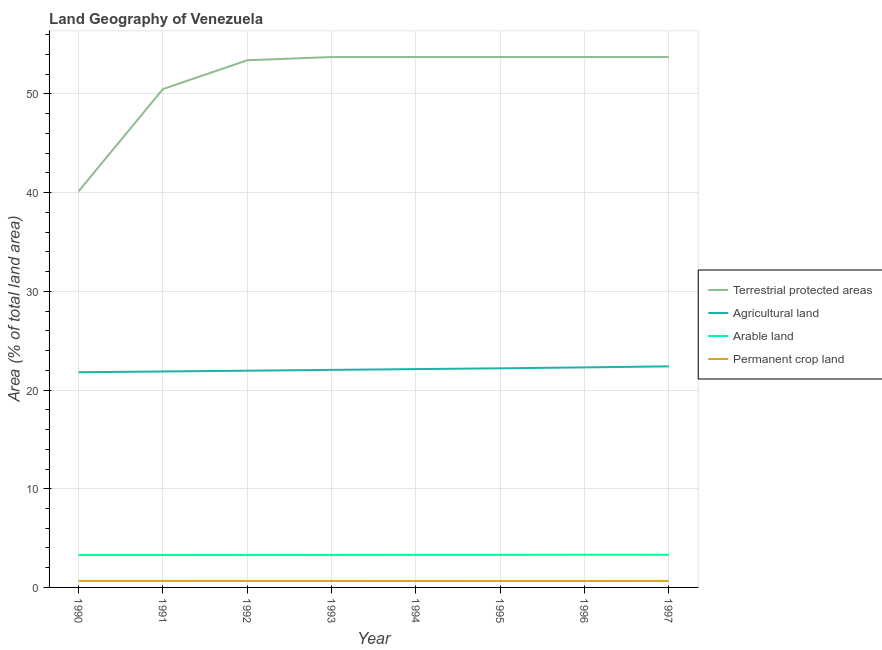Does the line corresponding to percentage of land under terrestrial protection intersect with the line corresponding to percentage of area under agricultural land?
Your answer should be very brief. No. What is the percentage of land under terrestrial protection in 1997?
Give a very brief answer. 53.75. Across all years, what is the maximum percentage of area under permanent crop land?
Give a very brief answer. 0.66. Across all years, what is the minimum percentage of area under permanent crop land?
Make the answer very short. 0.65. In which year was the percentage of land under terrestrial protection maximum?
Make the answer very short. 1993. What is the total percentage of area under permanent crop land in the graph?
Keep it short and to the point. 5.23. What is the difference between the percentage of area under arable land in 1993 and that in 1994?
Your answer should be compact. -0. What is the difference between the percentage of area under permanent crop land in 1992 and the percentage of land under terrestrial protection in 1993?
Offer a terse response. -53.09. What is the average percentage of area under permanent crop land per year?
Offer a very short reply. 0.65. In the year 1996, what is the difference between the percentage of area under agricultural land and percentage of area under permanent crop land?
Your response must be concise. 21.65. What is the ratio of the percentage of area under arable land in 1990 to that in 1992?
Your response must be concise. 1. Is the percentage of area under agricultural land in 1991 less than that in 1994?
Give a very brief answer. Yes. What is the difference between the highest and the second highest percentage of area under agricultural land?
Ensure brevity in your answer.  0.1. What is the difference between the highest and the lowest percentage of area under arable land?
Your answer should be very brief. 0.02. Is the sum of the percentage of area under arable land in 1993 and 1995 greater than the maximum percentage of area under permanent crop land across all years?
Give a very brief answer. Yes. Is it the case that in every year, the sum of the percentage of land under terrestrial protection and percentage of area under agricultural land is greater than the sum of percentage of area under arable land and percentage of area under permanent crop land?
Offer a very short reply. No. Does the percentage of area under permanent crop land monotonically increase over the years?
Provide a short and direct response. No. Is the percentage of area under permanent crop land strictly less than the percentage of area under arable land over the years?
Your answer should be compact. Yes. How are the legend labels stacked?
Make the answer very short. Vertical. What is the title of the graph?
Provide a succinct answer. Land Geography of Venezuela. What is the label or title of the X-axis?
Provide a short and direct response. Year. What is the label or title of the Y-axis?
Offer a terse response. Area (% of total land area). What is the Area (% of total land area) of Terrestrial protected areas in 1990?
Your answer should be compact. 40.15. What is the Area (% of total land area) of Agricultural land in 1990?
Provide a short and direct response. 21.8. What is the Area (% of total land area) in Arable land in 1990?
Offer a very short reply. 3.29. What is the Area (% of total land area) of Permanent crop land in 1990?
Your answer should be very brief. 0.66. What is the Area (% of total land area) of Terrestrial protected areas in 1991?
Your answer should be very brief. 50.5. What is the Area (% of total land area) of Agricultural land in 1991?
Keep it short and to the point. 21.88. What is the Area (% of total land area) in Arable land in 1991?
Give a very brief answer. 3.29. What is the Area (% of total land area) in Permanent crop land in 1991?
Provide a succinct answer. 0.66. What is the Area (% of total land area) of Terrestrial protected areas in 1992?
Ensure brevity in your answer.  53.42. What is the Area (% of total land area) in Agricultural land in 1992?
Your answer should be very brief. 21.96. What is the Area (% of total land area) in Arable land in 1992?
Offer a very short reply. 3.29. What is the Area (% of total land area) of Permanent crop land in 1992?
Offer a very short reply. 0.66. What is the Area (% of total land area) in Terrestrial protected areas in 1993?
Your answer should be compact. 53.75. What is the Area (% of total land area) of Agricultural land in 1993?
Ensure brevity in your answer.  22.04. What is the Area (% of total land area) of Arable land in 1993?
Make the answer very short. 3.3. What is the Area (% of total land area) of Permanent crop land in 1993?
Offer a very short reply. 0.65. What is the Area (% of total land area) in Terrestrial protected areas in 1994?
Ensure brevity in your answer.  53.75. What is the Area (% of total land area) in Agricultural land in 1994?
Ensure brevity in your answer.  22.12. What is the Area (% of total land area) of Arable land in 1994?
Offer a very short reply. 3.3. What is the Area (% of total land area) in Permanent crop land in 1994?
Your answer should be compact. 0.65. What is the Area (% of total land area) of Terrestrial protected areas in 1995?
Your response must be concise. 53.75. What is the Area (% of total land area) in Agricultural land in 1995?
Offer a very short reply. 22.2. What is the Area (% of total land area) of Arable land in 1995?
Keep it short and to the point. 3.3. What is the Area (% of total land area) in Permanent crop land in 1995?
Provide a succinct answer. 0.65. What is the Area (% of total land area) in Terrestrial protected areas in 1996?
Offer a very short reply. 53.75. What is the Area (% of total land area) in Agricultural land in 1996?
Give a very brief answer. 22.3. What is the Area (% of total land area) in Arable land in 1996?
Your answer should be compact. 3.31. What is the Area (% of total land area) in Permanent crop land in 1996?
Provide a short and direct response. 0.65. What is the Area (% of total land area) of Terrestrial protected areas in 1997?
Keep it short and to the point. 53.75. What is the Area (% of total land area) of Agricultural land in 1997?
Your answer should be compact. 22.4. What is the Area (% of total land area) in Arable land in 1997?
Give a very brief answer. 3.31. What is the Area (% of total land area) of Permanent crop land in 1997?
Offer a terse response. 0.66. Across all years, what is the maximum Area (% of total land area) of Terrestrial protected areas?
Ensure brevity in your answer.  53.75. Across all years, what is the maximum Area (% of total land area) in Agricultural land?
Make the answer very short. 22.4. Across all years, what is the maximum Area (% of total land area) in Arable land?
Your answer should be very brief. 3.31. Across all years, what is the maximum Area (% of total land area) of Permanent crop land?
Give a very brief answer. 0.66. Across all years, what is the minimum Area (% of total land area) of Terrestrial protected areas?
Your response must be concise. 40.15. Across all years, what is the minimum Area (% of total land area) in Agricultural land?
Your answer should be compact. 21.8. Across all years, what is the minimum Area (% of total land area) of Arable land?
Your response must be concise. 3.29. Across all years, what is the minimum Area (% of total land area) of Permanent crop land?
Keep it short and to the point. 0.65. What is the total Area (% of total land area) of Terrestrial protected areas in the graph?
Your answer should be very brief. 412.79. What is the total Area (% of total land area) of Agricultural land in the graph?
Make the answer very short. 176.72. What is the total Area (% of total land area) in Arable land in the graph?
Ensure brevity in your answer.  26.39. What is the total Area (% of total land area) in Permanent crop land in the graph?
Keep it short and to the point. 5.23. What is the difference between the Area (% of total land area) of Terrestrial protected areas in 1990 and that in 1991?
Your response must be concise. -10.36. What is the difference between the Area (% of total land area) in Agricultural land in 1990 and that in 1991?
Your answer should be very brief. -0.08. What is the difference between the Area (% of total land area) in Arable land in 1990 and that in 1991?
Provide a short and direct response. 0. What is the difference between the Area (% of total land area) of Terrestrial protected areas in 1990 and that in 1992?
Make the answer very short. -13.27. What is the difference between the Area (% of total land area) of Agricultural land in 1990 and that in 1992?
Ensure brevity in your answer.  -0.16. What is the difference between the Area (% of total land area) of Arable land in 1990 and that in 1992?
Provide a short and direct response. -0. What is the difference between the Area (% of total land area) in Permanent crop land in 1990 and that in 1992?
Ensure brevity in your answer.  0. What is the difference between the Area (% of total land area) of Terrestrial protected areas in 1990 and that in 1993?
Give a very brief answer. -13.6. What is the difference between the Area (% of total land area) in Agricultural land in 1990 and that in 1993?
Provide a short and direct response. -0.24. What is the difference between the Area (% of total land area) of Arable land in 1990 and that in 1993?
Your response must be concise. -0.01. What is the difference between the Area (% of total land area) of Permanent crop land in 1990 and that in 1993?
Keep it short and to the point. 0.01. What is the difference between the Area (% of total land area) of Terrestrial protected areas in 1990 and that in 1994?
Provide a succinct answer. -13.6. What is the difference between the Area (% of total land area) in Agricultural land in 1990 and that in 1994?
Provide a short and direct response. -0.32. What is the difference between the Area (% of total land area) in Arable land in 1990 and that in 1994?
Your answer should be compact. -0.01. What is the difference between the Area (% of total land area) of Permanent crop land in 1990 and that in 1994?
Offer a very short reply. 0.01. What is the difference between the Area (% of total land area) of Terrestrial protected areas in 1990 and that in 1995?
Make the answer very short. -13.6. What is the difference between the Area (% of total land area) of Agricultural land in 1990 and that in 1995?
Your response must be concise. -0.4. What is the difference between the Area (% of total land area) of Arable land in 1990 and that in 1995?
Your answer should be compact. -0.01. What is the difference between the Area (% of total land area) of Permanent crop land in 1990 and that in 1995?
Keep it short and to the point. 0.01. What is the difference between the Area (% of total land area) of Terrestrial protected areas in 1990 and that in 1996?
Keep it short and to the point. -13.6. What is the difference between the Area (% of total land area) in Agricultural land in 1990 and that in 1996?
Provide a succinct answer. -0.49. What is the difference between the Area (% of total land area) of Arable land in 1990 and that in 1996?
Provide a short and direct response. -0.02. What is the difference between the Area (% of total land area) of Permanent crop land in 1990 and that in 1996?
Keep it short and to the point. 0.01. What is the difference between the Area (% of total land area) in Terrestrial protected areas in 1990 and that in 1997?
Your answer should be very brief. -13.6. What is the difference between the Area (% of total land area) in Agricultural land in 1990 and that in 1997?
Offer a very short reply. -0.6. What is the difference between the Area (% of total land area) of Arable land in 1990 and that in 1997?
Give a very brief answer. -0.02. What is the difference between the Area (% of total land area) in Permanent crop land in 1990 and that in 1997?
Provide a succinct answer. 0. What is the difference between the Area (% of total land area) in Terrestrial protected areas in 1991 and that in 1992?
Provide a succinct answer. -2.92. What is the difference between the Area (% of total land area) of Agricultural land in 1991 and that in 1992?
Offer a terse response. -0.08. What is the difference between the Area (% of total land area) of Arable land in 1991 and that in 1992?
Provide a short and direct response. -0. What is the difference between the Area (% of total land area) in Permanent crop land in 1991 and that in 1992?
Provide a succinct answer. 0. What is the difference between the Area (% of total land area) in Terrestrial protected areas in 1991 and that in 1993?
Your answer should be compact. -3.25. What is the difference between the Area (% of total land area) in Agricultural land in 1991 and that in 1993?
Your response must be concise. -0.16. What is the difference between the Area (% of total land area) in Arable land in 1991 and that in 1993?
Provide a short and direct response. -0.01. What is the difference between the Area (% of total land area) of Permanent crop land in 1991 and that in 1993?
Offer a terse response. 0.01. What is the difference between the Area (% of total land area) of Terrestrial protected areas in 1991 and that in 1994?
Your answer should be very brief. -3.25. What is the difference between the Area (% of total land area) of Agricultural land in 1991 and that in 1994?
Provide a succinct answer. -0.24. What is the difference between the Area (% of total land area) of Arable land in 1991 and that in 1994?
Your answer should be compact. -0.01. What is the difference between the Area (% of total land area) in Permanent crop land in 1991 and that in 1994?
Your answer should be compact. 0.01. What is the difference between the Area (% of total land area) of Terrestrial protected areas in 1991 and that in 1995?
Give a very brief answer. -3.25. What is the difference between the Area (% of total land area) of Agricultural land in 1991 and that in 1995?
Provide a short and direct response. -0.32. What is the difference between the Area (% of total land area) of Arable land in 1991 and that in 1995?
Give a very brief answer. -0.01. What is the difference between the Area (% of total land area) of Permanent crop land in 1991 and that in 1995?
Offer a very short reply. 0.01. What is the difference between the Area (% of total land area) in Terrestrial protected areas in 1991 and that in 1996?
Provide a short and direct response. -3.25. What is the difference between the Area (% of total land area) of Agricultural land in 1991 and that in 1996?
Ensure brevity in your answer.  -0.41. What is the difference between the Area (% of total land area) of Arable land in 1991 and that in 1996?
Make the answer very short. -0.02. What is the difference between the Area (% of total land area) in Permanent crop land in 1991 and that in 1996?
Give a very brief answer. 0.01. What is the difference between the Area (% of total land area) of Terrestrial protected areas in 1991 and that in 1997?
Make the answer very short. -3.25. What is the difference between the Area (% of total land area) in Agricultural land in 1991 and that in 1997?
Ensure brevity in your answer.  -0.52. What is the difference between the Area (% of total land area) in Arable land in 1991 and that in 1997?
Provide a succinct answer. -0.02. What is the difference between the Area (% of total land area) of Permanent crop land in 1991 and that in 1997?
Provide a succinct answer. 0. What is the difference between the Area (% of total land area) in Terrestrial protected areas in 1992 and that in 1993?
Ensure brevity in your answer.  -0.33. What is the difference between the Area (% of total land area) in Agricultural land in 1992 and that in 1993?
Keep it short and to the point. -0.08. What is the difference between the Area (% of total land area) in Arable land in 1992 and that in 1993?
Ensure brevity in your answer.  -0. What is the difference between the Area (% of total land area) in Permanent crop land in 1992 and that in 1993?
Make the answer very short. 0. What is the difference between the Area (% of total land area) of Terrestrial protected areas in 1992 and that in 1994?
Your answer should be very brief. -0.33. What is the difference between the Area (% of total land area) of Agricultural land in 1992 and that in 1994?
Make the answer very short. -0.16. What is the difference between the Area (% of total land area) in Arable land in 1992 and that in 1994?
Give a very brief answer. -0.01. What is the difference between the Area (% of total land area) of Permanent crop land in 1992 and that in 1994?
Provide a short and direct response. 0.01. What is the difference between the Area (% of total land area) in Terrestrial protected areas in 1992 and that in 1995?
Give a very brief answer. -0.33. What is the difference between the Area (% of total land area) of Agricultural land in 1992 and that in 1995?
Provide a succinct answer. -0.24. What is the difference between the Area (% of total land area) in Arable land in 1992 and that in 1995?
Ensure brevity in your answer.  -0.01. What is the difference between the Area (% of total land area) in Permanent crop land in 1992 and that in 1995?
Offer a very short reply. 0.01. What is the difference between the Area (% of total land area) of Terrestrial protected areas in 1992 and that in 1996?
Provide a succinct answer. -0.33. What is the difference between the Area (% of total land area) of Arable land in 1992 and that in 1996?
Offer a very short reply. -0.02. What is the difference between the Area (% of total land area) of Permanent crop land in 1992 and that in 1996?
Make the answer very short. 0.01. What is the difference between the Area (% of total land area) in Terrestrial protected areas in 1992 and that in 1997?
Give a very brief answer. -0.33. What is the difference between the Area (% of total land area) in Agricultural land in 1992 and that in 1997?
Offer a very short reply. -0.44. What is the difference between the Area (% of total land area) of Arable land in 1992 and that in 1997?
Make the answer very short. -0.02. What is the difference between the Area (% of total land area) of Permanent crop land in 1992 and that in 1997?
Keep it short and to the point. 0. What is the difference between the Area (% of total land area) in Terrestrial protected areas in 1993 and that in 1994?
Make the answer very short. 0. What is the difference between the Area (% of total land area) in Agricultural land in 1993 and that in 1994?
Keep it short and to the point. -0.08. What is the difference between the Area (% of total land area) of Arable land in 1993 and that in 1994?
Ensure brevity in your answer.  -0. What is the difference between the Area (% of total land area) of Permanent crop land in 1993 and that in 1994?
Your answer should be compact. 0. What is the difference between the Area (% of total land area) of Terrestrial protected areas in 1993 and that in 1995?
Your answer should be compact. 0. What is the difference between the Area (% of total land area) of Agricultural land in 1993 and that in 1995?
Offer a very short reply. -0.16. What is the difference between the Area (% of total land area) in Arable land in 1993 and that in 1995?
Provide a succinct answer. -0.01. What is the difference between the Area (% of total land area) in Permanent crop land in 1993 and that in 1995?
Make the answer very short. 0.01. What is the difference between the Area (% of total land area) of Terrestrial protected areas in 1993 and that in 1996?
Your response must be concise. 0. What is the difference between the Area (% of total land area) in Agricultural land in 1993 and that in 1996?
Offer a terse response. -0.25. What is the difference between the Area (% of total land area) of Arable land in 1993 and that in 1996?
Offer a very short reply. -0.02. What is the difference between the Area (% of total land area) of Permanent crop land in 1993 and that in 1996?
Offer a terse response. 0. What is the difference between the Area (% of total land area) in Terrestrial protected areas in 1993 and that in 1997?
Make the answer very short. 0. What is the difference between the Area (% of total land area) in Agricultural land in 1993 and that in 1997?
Offer a very short reply. -0.36. What is the difference between the Area (% of total land area) in Arable land in 1993 and that in 1997?
Keep it short and to the point. -0.01. What is the difference between the Area (% of total land area) in Permanent crop land in 1993 and that in 1997?
Ensure brevity in your answer.  -0. What is the difference between the Area (% of total land area) of Agricultural land in 1994 and that in 1995?
Your answer should be very brief. -0.08. What is the difference between the Area (% of total land area) in Arable land in 1994 and that in 1995?
Provide a succinct answer. -0. What is the difference between the Area (% of total land area) in Permanent crop land in 1994 and that in 1995?
Your answer should be very brief. 0. What is the difference between the Area (% of total land area) in Terrestrial protected areas in 1994 and that in 1996?
Your response must be concise. 0. What is the difference between the Area (% of total land area) of Agricultural land in 1994 and that in 1996?
Offer a terse response. -0.17. What is the difference between the Area (% of total land area) of Arable land in 1994 and that in 1996?
Give a very brief answer. -0.01. What is the difference between the Area (% of total land area) of Permanent crop land in 1994 and that in 1996?
Give a very brief answer. -0. What is the difference between the Area (% of total land area) of Terrestrial protected areas in 1994 and that in 1997?
Provide a succinct answer. 0. What is the difference between the Area (% of total land area) of Agricultural land in 1994 and that in 1997?
Make the answer very short. -0.28. What is the difference between the Area (% of total land area) in Arable land in 1994 and that in 1997?
Your answer should be very brief. -0.01. What is the difference between the Area (% of total land area) in Permanent crop land in 1994 and that in 1997?
Provide a succinct answer. -0.01. What is the difference between the Area (% of total land area) in Terrestrial protected areas in 1995 and that in 1996?
Give a very brief answer. 0. What is the difference between the Area (% of total land area) of Agricultural land in 1995 and that in 1996?
Offer a terse response. -0.09. What is the difference between the Area (% of total land area) of Arable land in 1995 and that in 1996?
Keep it short and to the point. -0.01. What is the difference between the Area (% of total land area) of Permanent crop land in 1995 and that in 1996?
Give a very brief answer. -0. What is the difference between the Area (% of total land area) in Agricultural land in 1995 and that in 1997?
Provide a short and direct response. -0.2. What is the difference between the Area (% of total land area) in Arable land in 1995 and that in 1997?
Offer a very short reply. -0.01. What is the difference between the Area (% of total land area) in Permanent crop land in 1995 and that in 1997?
Provide a short and direct response. -0.01. What is the difference between the Area (% of total land area) of Terrestrial protected areas in 1996 and that in 1997?
Ensure brevity in your answer.  0. What is the difference between the Area (% of total land area) of Agricultural land in 1996 and that in 1997?
Provide a short and direct response. -0.1. What is the difference between the Area (% of total land area) of Arable land in 1996 and that in 1997?
Give a very brief answer. 0. What is the difference between the Area (% of total land area) in Permanent crop land in 1996 and that in 1997?
Offer a very short reply. -0.01. What is the difference between the Area (% of total land area) of Terrestrial protected areas in 1990 and the Area (% of total land area) of Agricultural land in 1991?
Provide a short and direct response. 18.26. What is the difference between the Area (% of total land area) in Terrestrial protected areas in 1990 and the Area (% of total land area) in Arable land in 1991?
Offer a terse response. 36.86. What is the difference between the Area (% of total land area) of Terrestrial protected areas in 1990 and the Area (% of total land area) of Permanent crop land in 1991?
Provide a short and direct response. 39.49. What is the difference between the Area (% of total land area) in Agricultural land in 1990 and the Area (% of total land area) in Arable land in 1991?
Your answer should be very brief. 18.52. What is the difference between the Area (% of total land area) of Agricultural land in 1990 and the Area (% of total land area) of Permanent crop land in 1991?
Offer a terse response. 21.14. What is the difference between the Area (% of total land area) of Arable land in 1990 and the Area (% of total land area) of Permanent crop land in 1991?
Offer a very short reply. 2.63. What is the difference between the Area (% of total land area) of Terrestrial protected areas in 1990 and the Area (% of total land area) of Agricultural land in 1992?
Offer a very short reply. 18.18. What is the difference between the Area (% of total land area) of Terrestrial protected areas in 1990 and the Area (% of total land area) of Arable land in 1992?
Offer a very short reply. 36.85. What is the difference between the Area (% of total land area) in Terrestrial protected areas in 1990 and the Area (% of total land area) in Permanent crop land in 1992?
Your answer should be compact. 39.49. What is the difference between the Area (% of total land area) of Agricultural land in 1990 and the Area (% of total land area) of Arable land in 1992?
Ensure brevity in your answer.  18.51. What is the difference between the Area (% of total land area) in Agricultural land in 1990 and the Area (% of total land area) in Permanent crop land in 1992?
Offer a terse response. 21.15. What is the difference between the Area (% of total land area) in Arable land in 1990 and the Area (% of total land area) in Permanent crop land in 1992?
Your response must be concise. 2.63. What is the difference between the Area (% of total land area) of Terrestrial protected areas in 1990 and the Area (% of total land area) of Agricultural land in 1993?
Your response must be concise. 18.1. What is the difference between the Area (% of total land area) of Terrestrial protected areas in 1990 and the Area (% of total land area) of Arable land in 1993?
Your answer should be very brief. 36.85. What is the difference between the Area (% of total land area) of Terrestrial protected areas in 1990 and the Area (% of total land area) of Permanent crop land in 1993?
Offer a terse response. 39.49. What is the difference between the Area (% of total land area) of Agricultural land in 1990 and the Area (% of total land area) of Arable land in 1993?
Keep it short and to the point. 18.51. What is the difference between the Area (% of total land area) of Agricultural land in 1990 and the Area (% of total land area) of Permanent crop land in 1993?
Your answer should be very brief. 21.15. What is the difference between the Area (% of total land area) in Arable land in 1990 and the Area (% of total land area) in Permanent crop land in 1993?
Your response must be concise. 2.63. What is the difference between the Area (% of total land area) of Terrestrial protected areas in 1990 and the Area (% of total land area) of Agricultural land in 1994?
Offer a very short reply. 18.02. What is the difference between the Area (% of total land area) of Terrestrial protected areas in 1990 and the Area (% of total land area) of Arable land in 1994?
Ensure brevity in your answer.  36.85. What is the difference between the Area (% of total land area) in Terrestrial protected areas in 1990 and the Area (% of total land area) in Permanent crop land in 1994?
Your answer should be very brief. 39.5. What is the difference between the Area (% of total land area) in Agricultural land in 1990 and the Area (% of total land area) in Arable land in 1994?
Keep it short and to the point. 18.5. What is the difference between the Area (% of total land area) of Agricultural land in 1990 and the Area (% of total land area) of Permanent crop land in 1994?
Make the answer very short. 21.15. What is the difference between the Area (% of total land area) in Arable land in 1990 and the Area (% of total land area) in Permanent crop land in 1994?
Provide a short and direct response. 2.64. What is the difference between the Area (% of total land area) in Terrestrial protected areas in 1990 and the Area (% of total land area) in Agricultural land in 1995?
Your answer should be very brief. 17.94. What is the difference between the Area (% of total land area) of Terrestrial protected areas in 1990 and the Area (% of total land area) of Arable land in 1995?
Your answer should be compact. 36.84. What is the difference between the Area (% of total land area) of Terrestrial protected areas in 1990 and the Area (% of total land area) of Permanent crop land in 1995?
Ensure brevity in your answer.  39.5. What is the difference between the Area (% of total land area) in Agricultural land in 1990 and the Area (% of total land area) in Arable land in 1995?
Offer a very short reply. 18.5. What is the difference between the Area (% of total land area) of Agricultural land in 1990 and the Area (% of total land area) of Permanent crop land in 1995?
Your response must be concise. 21.16. What is the difference between the Area (% of total land area) in Arable land in 1990 and the Area (% of total land area) in Permanent crop land in 1995?
Provide a succinct answer. 2.64. What is the difference between the Area (% of total land area) in Terrestrial protected areas in 1990 and the Area (% of total land area) in Agricultural land in 1996?
Provide a succinct answer. 17.85. What is the difference between the Area (% of total land area) of Terrestrial protected areas in 1990 and the Area (% of total land area) of Arable land in 1996?
Your answer should be compact. 36.83. What is the difference between the Area (% of total land area) in Terrestrial protected areas in 1990 and the Area (% of total land area) in Permanent crop land in 1996?
Your answer should be compact. 39.49. What is the difference between the Area (% of total land area) of Agricultural land in 1990 and the Area (% of total land area) of Arable land in 1996?
Your response must be concise. 18.49. What is the difference between the Area (% of total land area) of Agricultural land in 1990 and the Area (% of total land area) of Permanent crop land in 1996?
Make the answer very short. 21.15. What is the difference between the Area (% of total land area) in Arable land in 1990 and the Area (% of total land area) in Permanent crop land in 1996?
Offer a very short reply. 2.64. What is the difference between the Area (% of total land area) in Terrestrial protected areas in 1990 and the Area (% of total land area) in Agricultural land in 1997?
Provide a short and direct response. 17.75. What is the difference between the Area (% of total land area) of Terrestrial protected areas in 1990 and the Area (% of total land area) of Arable land in 1997?
Provide a succinct answer. 36.84. What is the difference between the Area (% of total land area) of Terrestrial protected areas in 1990 and the Area (% of total land area) of Permanent crop land in 1997?
Offer a terse response. 39.49. What is the difference between the Area (% of total land area) of Agricultural land in 1990 and the Area (% of total land area) of Arable land in 1997?
Your response must be concise. 18.49. What is the difference between the Area (% of total land area) in Agricultural land in 1990 and the Area (% of total land area) in Permanent crop land in 1997?
Your answer should be very brief. 21.15. What is the difference between the Area (% of total land area) of Arable land in 1990 and the Area (% of total land area) of Permanent crop land in 1997?
Provide a short and direct response. 2.63. What is the difference between the Area (% of total land area) in Terrestrial protected areas in 1991 and the Area (% of total land area) in Agricultural land in 1992?
Your answer should be very brief. 28.54. What is the difference between the Area (% of total land area) of Terrestrial protected areas in 1991 and the Area (% of total land area) of Arable land in 1992?
Ensure brevity in your answer.  47.21. What is the difference between the Area (% of total land area) in Terrestrial protected areas in 1991 and the Area (% of total land area) in Permanent crop land in 1992?
Your response must be concise. 49.84. What is the difference between the Area (% of total land area) of Agricultural land in 1991 and the Area (% of total land area) of Arable land in 1992?
Offer a very short reply. 18.59. What is the difference between the Area (% of total land area) in Agricultural land in 1991 and the Area (% of total land area) in Permanent crop land in 1992?
Offer a terse response. 21.23. What is the difference between the Area (% of total land area) in Arable land in 1991 and the Area (% of total land area) in Permanent crop land in 1992?
Make the answer very short. 2.63. What is the difference between the Area (% of total land area) in Terrestrial protected areas in 1991 and the Area (% of total land area) in Agricultural land in 1993?
Provide a short and direct response. 28.46. What is the difference between the Area (% of total land area) in Terrestrial protected areas in 1991 and the Area (% of total land area) in Arable land in 1993?
Your response must be concise. 47.21. What is the difference between the Area (% of total land area) of Terrestrial protected areas in 1991 and the Area (% of total land area) of Permanent crop land in 1993?
Offer a very short reply. 49.85. What is the difference between the Area (% of total land area) in Agricultural land in 1991 and the Area (% of total land area) in Arable land in 1993?
Your answer should be very brief. 18.59. What is the difference between the Area (% of total land area) in Agricultural land in 1991 and the Area (% of total land area) in Permanent crop land in 1993?
Give a very brief answer. 21.23. What is the difference between the Area (% of total land area) of Arable land in 1991 and the Area (% of total land area) of Permanent crop land in 1993?
Give a very brief answer. 2.63. What is the difference between the Area (% of total land area) in Terrestrial protected areas in 1991 and the Area (% of total land area) in Agricultural land in 1994?
Provide a short and direct response. 28.38. What is the difference between the Area (% of total land area) in Terrestrial protected areas in 1991 and the Area (% of total land area) in Arable land in 1994?
Your answer should be compact. 47.2. What is the difference between the Area (% of total land area) of Terrestrial protected areas in 1991 and the Area (% of total land area) of Permanent crop land in 1994?
Your answer should be compact. 49.85. What is the difference between the Area (% of total land area) of Agricultural land in 1991 and the Area (% of total land area) of Arable land in 1994?
Make the answer very short. 18.58. What is the difference between the Area (% of total land area) in Agricultural land in 1991 and the Area (% of total land area) in Permanent crop land in 1994?
Offer a very short reply. 21.23. What is the difference between the Area (% of total land area) in Arable land in 1991 and the Area (% of total land area) in Permanent crop land in 1994?
Provide a succinct answer. 2.64. What is the difference between the Area (% of total land area) in Terrestrial protected areas in 1991 and the Area (% of total land area) in Agricultural land in 1995?
Ensure brevity in your answer.  28.3. What is the difference between the Area (% of total land area) in Terrestrial protected areas in 1991 and the Area (% of total land area) in Arable land in 1995?
Keep it short and to the point. 47.2. What is the difference between the Area (% of total land area) of Terrestrial protected areas in 1991 and the Area (% of total land area) of Permanent crop land in 1995?
Provide a succinct answer. 49.85. What is the difference between the Area (% of total land area) in Agricultural land in 1991 and the Area (% of total land area) in Arable land in 1995?
Provide a succinct answer. 18.58. What is the difference between the Area (% of total land area) in Agricultural land in 1991 and the Area (% of total land area) in Permanent crop land in 1995?
Ensure brevity in your answer.  21.24. What is the difference between the Area (% of total land area) in Arable land in 1991 and the Area (% of total land area) in Permanent crop land in 1995?
Offer a very short reply. 2.64. What is the difference between the Area (% of total land area) in Terrestrial protected areas in 1991 and the Area (% of total land area) in Agricultural land in 1996?
Provide a short and direct response. 28.21. What is the difference between the Area (% of total land area) of Terrestrial protected areas in 1991 and the Area (% of total land area) of Arable land in 1996?
Offer a terse response. 47.19. What is the difference between the Area (% of total land area) of Terrestrial protected areas in 1991 and the Area (% of total land area) of Permanent crop land in 1996?
Your response must be concise. 49.85. What is the difference between the Area (% of total land area) of Agricultural land in 1991 and the Area (% of total land area) of Arable land in 1996?
Make the answer very short. 18.57. What is the difference between the Area (% of total land area) in Agricultural land in 1991 and the Area (% of total land area) in Permanent crop land in 1996?
Ensure brevity in your answer.  21.23. What is the difference between the Area (% of total land area) of Arable land in 1991 and the Area (% of total land area) of Permanent crop land in 1996?
Make the answer very short. 2.64. What is the difference between the Area (% of total land area) of Terrestrial protected areas in 1991 and the Area (% of total land area) of Agricultural land in 1997?
Provide a short and direct response. 28.1. What is the difference between the Area (% of total land area) in Terrestrial protected areas in 1991 and the Area (% of total land area) in Arable land in 1997?
Provide a short and direct response. 47.19. What is the difference between the Area (% of total land area) of Terrestrial protected areas in 1991 and the Area (% of total land area) of Permanent crop land in 1997?
Your answer should be very brief. 49.84. What is the difference between the Area (% of total land area) in Agricultural land in 1991 and the Area (% of total land area) in Arable land in 1997?
Your answer should be very brief. 18.57. What is the difference between the Area (% of total land area) in Agricultural land in 1991 and the Area (% of total land area) in Permanent crop land in 1997?
Your answer should be very brief. 21.23. What is the difference between the Area (% of total land area) of Arable land in 1991 and the Area (% of total land area) of Permanent crop land in 1997?
Keep it short and to the point. 2.63. What is the difference between the Area (% of total land area) of Terrestrial protected areas in 1992 and the Area (% of total land area) of Agricultural land in 1993?
Offer a very short reply. 31.37. What is the difference between the Area (% of total land area) in Terrestrial protected areas in 1992 and the Area (% of total land area) in Arable land in 1993?
Offer a very short reply. 50.12. What is the difference between the Area (% of total land area) in Terrestrial protected areas in 1992 and the Area (% of total land area) in Permanent crop land in 1993?
Your response must be concise. 52.76. What is the difference between the Area (% of total land area) in Agricultural land in 1992 and the Area (% of total land area) in Arable land in 1993?
Your answer should be compact. 18.67. What is the difference between the Area (% of total land area) in Agricultural land in 1992 and the Area (% of total land area) in Permanent crop land in 1993?
Ensure brevity in your answer.  21.31. What is the difference between the Area (% of total land area) in Arable land in 1992 and the Area (% of total land area) in Permanent crop land in 1993?
Your response must be concise. 2.64. What is the difference between the Area (% of total land area) of Terrestrial protected areas in 1992 and the Area (% of total land area) of Agricultural land in 1994?
Your response must be concise. 31.29. What is the difference between the Area (% of total land area) of Terrestrial protected areas in 1992 and the Area (% of total land area) of Arable land in 1994?
Offer a very short reply. 50.12. What is the difference between the Area (% of total land area) in Terrestrial protected areas in 1992 and the Area (% of total land area) in Permanent crop land in 1994?
Make the answer very short. 52.77. What is the difference between the Area (% of total land area) of Agricultural land in 1992 and the Area (% of total land area) of Arable land in 1994?
Your answer should be compact. 18.66. What is the difference between the Area (% of total land area) of Agricultural land in 1992 and the Area (% of total land area) of Permanent crop land in 1994?
Provide a short and direct response. 21.31. What is the difference between the Area (% of total land area) in Arable land in 1992 and the Area (% of total land area) in Permanent crop land in 1994?
Provide a short and direct response. 2.64. What is the difference between the Area (% of total land area) in Terrestrial protected areas in 1992 and the Area (% of total land area) in Agricultural land in 1995?
Your response must be concise. 31.21. What is the difference between the Area (% of total land area) of Terrestrial protected areas in 1992 and the Area (% of total land area) of Arable land in 1995?
Offer a terse response. 50.11. What is the difference between the Area (% of total land area) in Terrestrial protected areas in 1992 and the Area (% of total land area) in Permanent crop land in 1995?
Give a very brief answer. 52.77. What is the difference between the Area (% of total land area) in Agricultural land in 1992 and the Area (% of total land area) in Arable land in 1995?
Offer a terse response. 18.66. What is the difference between the Area (% of total land area) in Agricultural land in 1992 and the Area (% of total land area) in Permanent crop land in 1995?
Provide a succinct answer. 21.32. What is the difference between the Area (% of total land area) of Arable land in 1992 and the Area (% of total land area) of Permanent crop land in 1995?
Offer a terse response. 2.64. What is the difference between the Area (% of total land area) in Terrestrial protected areas in 1992 and the Area (% of total land area) in Agricultural land in 1996?
Offer a terse response. 31.12. What is the difference between the Area (% of total land area) in Terrestrial protected areas in 1992 and the Area (% of total land area) in Arable land in 1996?
Offer a very short reply. 50.1. What is the difference between the Area (% of total land area) in Terrestrial protected areas in 1992 and the Area (% of total land area) in Permanent crop land in 1996?
Provide a short and direct response. 52.77. What is the difference between the Area (% of total land area) of Agricultural land in 1992 and the Area (% of total land area) of Arable land in 1996?
Ensure brevity in your answer.  18.65. What is the difference between the Area (% of total land area) of Agricultural land in 1992 and the Area (% of total land area) of Permanent crop land in 1996?
Provide a succinct answer. 21.31. What is the difference between the Area (% of total land area) in Arable land in 1992 and the Area (% of total land area) in Permanent crop land in 1996?
Provide a short and direct response. 2.64. What is the difference between the Area (% of total land area) of Terrestrial protected areas in 1992 and the Area (% of total land area) of Agricultural land in 1997?
Your answer should be very brief. 31.02. What is the difference between the Area (% of total land area) in Terrestrial protected areas in 1992 and the Area (% of total land area) in Arable land in 1997?
Your response must be concise. 50.11. What is the difference between the Area (% of total land area) in Terrestrial protected areas in 1992 and the Area (% of total land area) in Permanent crop land in 1997?
Give a very brief answer. 52.76. What is the difference between the Area (% of total land area) of Agricultural land in 1992 and the Area (% of total land area) of Arable land in 1997?
Provide a succinct answer. 18.65. What is the difference between the Area (% of total land area) of Agricultural land in 1992 and the Area (% of total land area) of Permanent crop land in 1997?
Your response must be concise. 21.31. What is the difference between the Area (% of total land area) of Arable land in 1992 and the Area (% of total land area) of Permanent crop land in 1997?
Ensure brevity in your answer.  2.63. What is the difference between the Area (% of total land area) in Terrestrial protected areas in 1993 and the Area (% of total land area) in Agricultural land in 1994?
Your answer should be compact. 31.62. What is the difference between the Area (% of total land area) of Terrestrial protected areas in 1993 and the Area (% of total land area) of Arable land in 1994?
Give a very brief answer. 50.45. What is the difference between the Area (% of total land area) in Terrestrial protected areas in 1993 and the Area (% of total land area) in Permanent crop land in 1994?
Provide a short and direct response. 53.1. What is the difference between the Area (% of total land area) of Agricultural land in 1993 and the Area (% of total land area) of Arable land in 1994?
Provide a short and direct response. 18.74. What is the difference between the Area (% of total land area) in Agricultural land in 1993 and the Area (% of total land area) in Permanent crop land in 1994?
Provide a short and direct response. 21.39. What is the difference between the Area (% of total land area) in Arable land in 1993 and the Area (% of total land area) in Permanent crop land in 1994?
Offer a terse response. 2.65. What is the difference between the Area (% of total land area) of Terrestrial protected areas in 1993 and the Area (% of total land area) of Agricultural land in 1995?
Give a very brief answer. 31.54. What is the difference between the Area (% of total land area) of Terrestrial protected areas in 1993 and the Area (% of total land area) of Arable land in 1995?
Make the answer very short. 50.44. What is the difference between the Area (% of total land area) in Terrestrial protected areas in 1993 and the Area (% of total land area) in Permanent crop land in 1995?
Your answer should be compact. 53.1. What is the difference between the Area (% of total land area) in Agricultural land in 1993 and the Area (% of total land area) in Arable land in 1995?
Provide a succinct answer. 18.74. What is the difference between the Area (% of total land area) in Agricultural land in 1993 and the Area (% of total land area) in Permanent crop land in 1995?
Your answer should be very brief. 21.4. What is the difference between the Area (% of total land area) of Arable land in 1993 and the Area (% of total land area) of Permanent crop land in 1995?
Give a very brief answer. 2.65. What is the difference between the Area (% of total land area) of Terrestrial protected areas in 1993 and the Area (% of total land area) of Agricultural land in 1996?
Make the answer very short. 31.45. What is the difference between the Area (% of total land area) in Terrestrial protected areas in 1993 and the Area (% of total land area) in Arable land in 1996?
Ensure brevity in your answer.  50.43. What is the difference between the Area (% of total land area) of Terrestrial protected areas in 1993 and the Area (% of total land area) of Permanent crop land in 1996?
Provide a succinct answer. 53.1. What is the difference between the Area (% of total land area) in Agricultural land in 1993 and the Area (% of total land area) in Arable land in 1996?
Your answer should be compact. 18.73. What is the difference between the Area (% of total land area) of Agricultural land in 1993 and the Area (% of total land area) of Permanent crop land in 1996?
Make the answer very short. 21.39. What is the difference between the Area (% of total land area) of Arable land in 1993 and the Area (% of total land area) of Permanent crop land in 1996?
Provide a short and direct response. 2.65. What is the difference between the Area (% of total land area) in Terrestrial protected areas in 1993 and the Area (% of total land area) in Agricultural land in 1997?
Your answer should be compact. 31.35. What is the difference between the Area (% of total land area) in Terrestrial protected areas in 1993 and the Area (% of total land area) in Arable land in 1997?
Make the answer very short. 50.44. What is the difference between the Area (% of total land area) of Terrestrial protected areas in 1993 and the Area (% of total land area) of Permanent crop land in 1997?
Your response must be concise. 53.09. What is the difference between the Area (% of total land area) of Agricultural land in 1993 and the Area (% of total land area) of Arable land in 1997?
Provide a short and direct response. 18.73. What is the difference between the Area (% of total land area) of Agricultural land in 1993 and the Area (% of total land area) of Permanent crop land in 1997?
Ensure brevity in your answer.  21.39. What is the difference between the Area (% of total land area) of Arable land in 1993 and the Area (% of total land area) of Permanent crop land in 1997?
Make the answer very short. 2.64. What is the difference between the Area (% of total land area) in Terrestrial protected areas in 1994 and the Area (% of total land area) in Agricultural land in 1995?
Offer a terse response. 31.54. What is the difference between the Area (% of total land area) in Terrestrial protected areas in 1994 and the Area (% of total land area) in Arable land in 1995?
Make the answer very short. 50.44. What is the difference between the Area (% of total land area) in Terrestrial protected areas in 1994 and the Area (% of total land area) in Permanent crop land in 1995?
Keep it short and to the point. 53.1. What is the difference between the Area (% of total land area) in Agricultural land in 1994 and the Area (% of total land area) in Arable land in 1995?
Ensure brevity in your answer.  18.82. What is the difference between the Area (% of total land area) in Agricultural land in 1994 and the Area (% of total land area) in Permanent crop land in 1995?
Provide a succinct answer. 21.48. What is the difference between the Area (% of total land area) in Arable land in 1994 and the Area (% of total land area) in Permanent crop land in 1995?
Give a very brief answer. 2.65. What is the difference between the Area (% of total land area) in Terrestrial protected areas in 1994 and the Area (% of total land area) in Agricultural land in 1996?
Your answer should be compact. 31.45. What is the difference between the Area (% of total land area) in Terrestrial protected areas in 1994 and the Area (% of total land area) in Arable land in 1996?
Your answer should be very brief. 50.43. What is the difference between the Area (% of total land area) in Terrestrial protected areas in 1994 and the Area (% of total land area) in Permanent crop land in 1996?
Make the answer very short. 53.1. What is the difference between the Area (% of total land area) in Agricultural land in 1994 and the Area (% of total land area) in Arable land in 1996?
Provide a succinct answer. 18.81. What is the difference between the Area (% of total land area) in Agricultural land in 1994 and the Area (% of total land area) in Permanent crop land in 1996?
Your answer should be compact. 21.47. What is the difference between the Area (% of total land area) of Arable land in 1994 and the Area (% of total land area) of Permanent crop land in 1996?
Ensure brevity in your answer.  2.65. What is the difference between the Area (% of total land area) of Terrestrial protected areas in 1994 and the Area (% of total land area) of Agricultural land in 1997?
Ensure brevity in your answer.  31.35. What is the difference between the Area (% of total land area) of Terrestrial protected areas in 1994 and the Area (% of total land area) of Arable land in 1997?
Offer a terse response. 50.44. What is the difference between the Area (% of total land area) in Terrestrial protected areas in 1994 and the Area (% of total land area) in Permanent crop land in 1997?
Offer a very short reply. 53.09. What is the difference between the Area (% of total land area) in Agricultural land in 1994 and the Area (% of total land area) in Arable land in 1997?
Your answer should be compact. 18.81. What is the difference between the Area (% of total land area) in Agricultural land in 1994 and the Area (% of total land area) in Permanent crop land in 1997?
Your answer should be compact. 21.47. What is the difference between the Area (% of total land area) in Arable land in 1994 and the Area (% of total land area) in Permanent crop land in 1997?
Your answer should be compact. 2.64. What is the difference between the Area (% of total land area) in Terrestrial protected areas in 1995 and the Area (% of total land area) in Agricultural land in 1996?
Provide a succinct answer. 31.45. What is the difference between the Area (% of total land area) in Terrestrial protected areas in 1995 and the Area (% of total land area) in Arable land in 1996?
Provide a succinct answer. 50.43. What is the difference between the Area (% of total land area) in Terrestrial protected areas in 1995 and the Area (% of total land area) in Permanent crop land in 1996?
Offer a very short reply. 53.1. What is the difference between the Area (% of total land area) of Agricultural land in 1995 and the Area (% of total land area) of Arable land in 1996?
Make the answer very short. 18.89. What is the difference between the Area (% of total land area) of Agricultural land in 1995 and the Area (% of total land area) of Permanent crop land in 1996?
Your answer should be very brief. 21.55. What is the difference between the Area (% of total land area) in Arable land in 1995 and the Area (% of total land area) in Permanent crop land in 1996?
Provide a short and direct response. 2.65. What is the difference between the Area (% of total land area) in Terrestrial protected areas in 1995 and the Area (% of total land area) in Agricultural land in 1997?
Provide a short and direct response. 31.35. What is the difference between the Area (% of total land area) in Terrestrial protected areas in 1995 and the Area (% of total land area) in Arable land in 1997?
Give a very brief answer. 50.44. What is the difference between the Area (% of total land area) of Terrestrial protected areas in 1995 and the Area (% of total land area) of Permanent crop land in 1997?
Provide a succinct answer. 53.09. What is the difference between the Area (% of total land area) in Agricultural land in 1995 and the Area (% of total land area) in Arable land in 1997?
Provide a short and direct response. 18.89. What is the difference between the Area (% of total land area) in Agricultural land in 1995 and the Area (% of total land area) in Permanent crop land in 1997?
Make the answer very short. 21.55. What is the difference between the Area (% of total land area) in Arable land in 1995 and the Area (% of total land area) in Permanent crop land in 1997?
Give a very brief answer. 2.65. What is the difference between the Area (% of total land area) of Terrestrial protected areas in 1996 and the Area (% of total land area) of Agricultural land in 1997?
Your answer should be compact. 31.35. What is the difference between the Area (% of total land area) in Terrestrial protected areas in 1996 and the Area (% of total land area) in Arable land in 1997?
Provide a short and direct response. 50.44. What is the difference between the Area (% of total land area) in Terrestrial protected areas in 1996 and the Area (% of total land area) in Permanent crop land in 1997?
Your response must be concise. 53.09. What is the difference between the Area (% of total land area) of Agricultural land in 1996 and the Area (% of total land area) of Arable land in 1997?
Give a very brief answer. 18.99. What is the difference between the Area (% of total land area) in Agricultural land in 1996 and the Area (% of total land area) in Permanent crop land in 1997?
Offer a terse response. 21.64. What is the difference between the Area (% of total land area) of Arable land in 1996 and the Area (% of total land area) of Permanent crop land in 1997?
Provide a succinct answer. 2.66. What is the average Area (% of total land area) of Terrestrial protected areas per year?
Provide a succinct answer. 51.6. What is the average Area (% of total land area) in Agricultural land per year?
Your response must be concise. 22.09. What is the average Area (% of total land area) in Arable land per year?
Offer a very short reply. 3.3. What is the average Area (% of total land area) of Permanent crop land per year?
Ensure brevity in your answer.  0.65. In the year 1990, what is the difference between the Area (% of total land area) of Terrestrial protected areas and Area (% of total land area) of Agricultural land?
Your answer should be compact. 18.34. In the year 1990, what is the difference between the Area (% of total land area) of Terrestrial protected areas and Area (% of total land area) of Arable land?
Keep it short and to the point. 36.86. In the year 1990, what is the difference between the Area (% of total land area) of Terrestrial protected areas and Area (% of total land area) of Permanent crop land?
Provide a short and direct response. 39.49. In the year 1990, what is the difference between the Area (% of total land area) in Agricultural land and Area (% of total land area) in Arable land?
Your response must be concise. 18.52. In the year 1990, what is the difference between the Area (% of total land area) of Agricultural land and Area (% of total land area) of Permanent crop land?
Your response must be concise. 21.14. In the year 1990, what is the difference between the Area (% of total land area) of Arable land and Area (% of total land area) of Permanent crop land?
Your answer should be compact. 2.63. In the year 1991, what is the difference between the Area (% of total land area) in Terrestrial protected areas and Area (% of total land area) in Agricultural land?
Give a very brief answer. 28.62. In the year 1991, what is the difference between the Area (% of total land area) in Terrestrial protected areas and Area (% of total land area) in Arable land?
Your response must be concise. 47.21. In the year 1991, what is the difference between the Area (% of total land area) in Terrestrial protected areas and Area (% of total land area) in Permanent crop land?
Your response must be concise. 49.84. In the year 1991, what is the difference between the Area (% of total land area) in Agricultural land and Area (% of total land area) in Arable land?
Provide a short and direct response. 18.6. In the year 1991, what is the difference between the Area (% of total land area) of Agricultural land and Area (% of total land area) of Permanent crop land?
Keep it short and to the point. 21.22. In the year 1991, what is the difference between the Area (% of total land area) in Arable land and Area (% of total land area) in Permanent crop land?
Keep it short and to the point. 2.63. In the year 1992, what is the difference between the Area (% of total land area) in Terrestrial protected areas and Area (% of total land area) in Agricultural land?
Provide a short and direct response. 31.45. In the year 1992, what is the difference between the Area (% of total land area) in Terrestrial protected areas and Area (% of total land area) in Arable land?
Offer a very short reply. 50.13. In the year 1992, what is the difference between the Area (% of total land area) in Terrestrial protected areas and Area (% of total land area) in Permanent crop land?
Provide a succinct answer. 52.76. In the year 1992, what is the difference between the Area (% of total land area) of Agricultural land and Area (% of total land area) of Arable land?
Keep it short and to the point. 18.67. In the year 1992, what is the difference between the Area (% of total land area) of Agricultural land and Area (% of total land area) of Permanent crop land?
Offer a very short reply. 21.31. In the year 1992, what is the difference between the Area (% of total land area) in Arable land and Area (% of total land area) in Permanent crop land?
Provide a succinct answer. 2.63. In the year 1993, what is the difference between the Area (% of total land area) of Terrestrial protected areas and Area (% of total land area) of Agricultural land?
Offer a terse response. 31.7. In the year 1993, what is the difference between the Area (% of total land area) in Terrestrial protected areas and Area (% of total land area) in Arable land?
Give a very brief answer. 50.45. In the year 1993, what is the difference between the Area (% of total land area) of Terrestrial protected areas and Area (% of total land area) of Permanent crop land?
Make the answer very short. 53.09. In the year 1993, what is the difference between the Area (% of total land area) in Agricultural land and Area (% of total land area) in Arable land?
Your answer should be compact. 18.75. In the year 1993, what is the difference between the Area (% of total land area) of Agricultural land and Area (% of total land area) of Permanent crop land?
Your answer should be compact. 21.39. In the year 1993, what is the difference between the Area (% of total land area) in Arable land and Area (% of total land area) in Permanent crop land?
Your response must be concise. 2.64. In the year 1994, what is the difference between the Area (% of total land area) of Terrestrial protected areas and Area (% of total land area) of Agricultural land?
Your answer should be compact. 31.62. In the year 1994, what is the difference between the Area (% of total land area) in Terrestrial protected areas and Area (% of total land area) in Arable land?
Your answer should be compact. 50.45. In the year 1994, what is the difference between the Area (% of total land area) of Terrestrial protected areas and Area (% of total land area) of Permanent crop land?
Keep it short and to the point. 53.1. In the year 1994, what is the difference between the Area (% of total land area) of Agricultural land and Area (% of total land area) of Arable land?
Offer a terse response. 18.82. In the year 1994, what is the difference between the Area (% of total land area) of Agricultural land and Area (% of total land area) of Permanent crop land?
Offer a very short reply. 21.47. In the year 1994, what is the difference between the Area (% of total land area) in Arable land and Area (% of total land area) in Permanent crop land?
Make the answer very short. 2.65. In the year 1995, what is the difference between the Area (% of total land area) of Terrestrial protected areas and Area (% of total land area) of Agricultural land?
Your answer should be compact. 31.54. In the year 1995, what is the difference between the Area (% of total land area) of Terrestrial protected areas and Area (% of total land area) of Arable land?
Provide a short and direct response. 50.44. In the year 1995, what is the difference between the Area (% of total land area) of Terrestrial protected areas and Area (% of total land area) of Permanent crop land?
Keep it short and to the point. 53.1. In the year 1995, what is the difference between the Area (% of total land area) of Agricultural land and Area (% of total land area) of Arable land?
Your answer should be compact. 18.9. In the year 1995, what is the difference between the Area (% of total land area) of Agricultural land and Area (% of total land area) of Permanent crop land?
Keep it short and to the point. 21.56. In the year 1995, what is the difference between the Area (% of total land area) in Arable land and Area (% of total land area) in Permanent crop land?
Ensure brevity in your answer.  2.66. In the year 1996, what is the difference between the Area (% of total land area) in Terrestrial protected areas and Area (% of total land area) in Agricultural land?
Provide a succinct answer. 31.45. In the year 1996, what is the difference between the Area (% of total land area) of Terrestrial protected areas and Area (% of total land area) of Arable land?
Ensure brevity in your answer.  50.43. In the year 1996, what is the difference between the Area (% of total land area) of Terrestrial protected areas and Area (% of total land area) of Permanent crop land?
Ensure brevity in your answer.  53.1. In the year 1996, what is the difference between the Area (% of total land area) of Agricultural land and Area (% of total land area) of Arable land?
Give a very brief answer. 18.98. In the year 1996, what is the difference between the Area (% of total land area) in Agricultural land and Area (% of total land area) in Permanent crop land?
Provide a succinct answer. 21.64. In the year 1996, what is the difference between the Area (% of total land area) in Arable land and Area (% of total land area) in Permanent crop land?
Provide a short and direct response. 2.66. In the year 1997, what is the difference between the Area (% of total land area) in Terrestrial protected areas and Area (% of total land area) in Agricultural land?
Your answer should be very brief. 31.35. In the year 1997, what is the difference between the Area (% of total land area) in Terrestrial protected areas and Area (% of total land area) in Arable land?
Provide a short and direct response. 50.44. In the year 1997, what is the difference between the Area (% of total land area) in Terrestrial protected areas and Area (% of total land area) in Permanent crop land?
Your answer should be very brief. 53.09. In the year 1997, what is the difference between the Area (% of total land area) in Agricultural land and Area (% of total land area) in Arable land?
Give a very brief answer. 19.09. In the year 1997, what is the difference between the Area (% of total land area) in Agricultural land and Area (% of total land area) in Permanent crop land?
Ensure brevity in your answer.  21.74. In the year 1997, what is the difference between the Area (% of total land area) in Arable land and Area (% of total land area) in Permanent crop land?
Ensure brevity in your answer.  2.65. What is the ratio of the Area (% of total land area) in Terrestrial protected areas in 1990 to that in 1991?
Provide a succinct answer. 0.79. What is the ratio of the Area (% of total land area) in Agricultural land in 1990 to that in 1991?
Provide a succinct answer. 1. What is the ratio of the Area (% of total land area) in Arable land in 1990 to that in 1991?
Keep it short and to the point. 1. What is the ratio of the Area (% of total land area) of Permanent crop land in 1990 to that in 1991?
Offer a terse response. 1. What is the ratio of the Area (% of total land area) in Terrestrial protected areas in 1990 to that in 1992?
Keep it short and to the point. 0.75. What is the ratio of the Area (% of total land area) of Agricultural land in 1990 to that in 1992?
Your answer should be very brief. 0.99. What is the ratio of the Area (% of total land area) in Permanent crop land in 1990 to that in 1992?
Keep it short and to the point. 1.01. What is the ratio of the Area (% of total land area) in Terrestrial protected areas in 1990 to that in 1993?
Make the answer very short. 0.75. What is the ratio of the Area (% of total land area) in Agricultural land in 1990 to that in 1993?
Provide a succinct answer. 0.99. What is the ratio of the Area (% of total land area) in Arable land in 1990 to that in 1993?
Provide a succinct answer. 1. What is the ratio of the Area (% of total land area) of Permanent crop land in 1990 to that in 1993?
Offer a very short reply. 1.01. What is the ratio of the Area (% of total land area) in Terrestrial protected areas in 1990 to that in 1994?
Your answer should be compact. 0.75. What is the ratio of the Area (% of total land area) of Agricultural land in 1990 to that in 1994?
Offer a very short reply. 0.99. What is the ratio of the Area (% of total land area) in Permanent crop land in 1990 to that in 1994?
Give a very brief answer. 1.02. What is the ratio of the Area (% of total land area) in Terrestrial protected areas in 1990 to that in 1995?
Ensure brevity in your answer.  0.75. What is the ratio of the Area (% of total land area) of Permanent crop land in 1990 to that in 1995?
Offer a terse response. 1.02. What is the ratio of the Area (% of total land area) in Terrestrial protected areas in 1990 to that in 1996?
Provide a short and direct response. 0.75. What is the ratio of the Area (% of total land area) of Agricultural land in 1990 to that in 1996?
Offer a very short reply. 0.98. What is the ratio of the Area (% of total land area) of Permanent crop land in 1990 to that in 1996?
Offer a very short reply. 1.01. What is the ratio of the Area (% of total land area) of Terrestrial protected areas in 1990 to that in 1997?
Keep it short and to the point. 0.75. What is the ratio of the Area (% of total land area) in Agricultural land in 1990 to that in 1997?
Offer a terse response. 0.97. What is the ratio of the Area (% of total land area) of Terrestrial protected areas in 1991 to that in 1992?
Your response must be concise. 0.95. What is the ratio of the Area (% of total land area) of Permanent crop land in 1991 to that in 1992?
Make the answer very short. 1.01. What is the ratio of the Area (% of total land area) in Terrestrial protected areas in 1991 to that in 1993?
Ensure brevity in your answer.  0.94. What is the ratio of the Area (% of total land area) in Permanent crop land in 1991 to that in 1993?
Keep it short and to the point. 1.01. What is the ratio of the Area (% of total land area) of Terrestrial protected areas in 1991 to that in 1994?
Your answer should be compact. 0.94. What is the ratio of the Area (% of total land area) of Agricultural land in 1991 to that in 1994?
Provide a short and direct response. 0.99. What is the ratio of the Area (% of total land area) in Arable land in 1991 to that in 1994?
Give a very brief answer. 1. What is the ratio of the Area (% of total land area) of Permanent crop land in 1991 to that in 1994?
Offer a terse response. 1.02. What is the ratio of the Area (% of total land area) of Terrestrial protected areas in 1991 to that in 1995?
Your response must be concise. 0.94. What is the ratio of the Area (% of total land area) in Agricultural land in 1991 to that in 1995?
Offer a terse response. 0.99. What is the ratio of the Area (% of total land area) in Arable land in 1991 to that in 1995?
Provide a short and direct response. 1. What is the ratio of the Area (% of total land area) of Permanent crop land in 1991 to that in 1995?
Your answer should be very brief. 1.02. What is the ratio of the Area (% of total land area) in Terrestrial protected areas in 1991 to that in 1996?
Keep it short and to the point. 0.94. What is the ratio of the Area (% of total land area) in Agricultural land in 1991 to that in 1996?
Make the answer very short. 0.98. What is the ratio of the Area (% of total land area) in Permanent crop land in 1991 to that in 1996?
Your answer should be compact. 1.01. What is the ratio of the Area (% of total land area) in Terrestrial protected areas in 1991 to that in 1997?
Provide a short and direct response. 0.94. What is the ratio of the Area (% of total land area) in Agricultural land in 1991 to that in 1997?
Your answer should be compact. 0.98. What is the ratio of the Area (% of total land area) in Permanent crop land in 1992 to that in 1993?
Offer a very short reply. 1. What is the ratio of the Area (% of total land area) in Permanent crop land in 1992 to that in 1994?
Provide a succinct answer. 1.01. What is the ratio of the Area (% of total land area) in Permanent crop land in 1992 to that in 1995?
Keep it short and to the point. 1.01. What is the ratio of the Area (% of total land area) in Agricultural land in 1992 to that in 1996?
Your answer should be very brief. 0.99. What is the ratio of the Area (% of total land area) in Arable land in 1992 to that in 1996?
Provide a short and direct response. 0.99. What is the ratio of the Area (% of total land area) of Permanent crop land in 1992 to that in 1996?
Make the answer very short. 1.01. What is the ratio of the Area (% of total land area) of Agricultural land in 1992 to that in 1997?
Your answer should be very brief. 0.98. What is the ratio of the Area (% of total land area) in Arable land in 1992 to that in 1997?
Provide a succinct answer. 0.99. What is the ratio of the Area (% of total land area) in Permanent crop land in 1992 to that in 1997?
Provide a succinct answer. 1. What is the ratio of the Area (% of total land area) in Agricultural land in 1993 to that in 1994?
Provide a short and direct response. 1. What is the ratio of the Area (% of total land area) of Terrestrial protected areas in 1993 to that in 1995?
Keep it short and to the point. 1. What is the ratio of the Area (% of total land area) in Permanent crop land in 1993 to that in 1995?
Offer a terse response. 1.01. What is the ratio of the Area (% of total land area) of Terrestrial protected areas in 1993 to that in 1996?
Offer a very short reply. 1. What is the ratio of the Area (% of total land area) in Agricultural land in 1993 to that in 1996?
Your answer should be very brief. 0.99. What is the ratio of the Area (% of total land area) in Arable land in 1993 to that in 1996?
Provide a succinct answer. 0.99. What is the ratio of the Area (% of total land area) in Agricultural land in 1993 to that in 1997?
Keep it short and to the point. 0.98. What is the ratio of the Area (% of total land area) in Permanent crop land in 1993 to that in 1997?
Provide a succinct answer. 1. What is the ratio of the Area (% of total land area) of Terrestrial protected areas in 1994 to that in 1995?
Your response must be concise. 1. What is the ratio of the Area (% of total land area) of Terrestrial protected areas in 1994 to that in 1996?
Offer a very short reply. 1. What is the ratio of the Area (% of total land area) of Agricultural land in 1994 to that in 1996?
Give a very brief answer. 0.99. What is the ratio of the Area (% of total land area) in Arable land in 1994 to that in 1996?
Make the answer very short. 1. What is the ratio of the Area (% of total land area) of Terrestrial protected areas in 1994 to that in 1997?
Keep it short and to the point. 1. What is the ratio of the Area (% of total land area) in Arable land in 1994 to that in 1997?
Make the answer very short. 1. What is the ratio of the Area (% of total land area) of Terrestrial protected areas in 1995 to that in 1996?
Your response must be concise. 1. What is the ratio of the Area (% of total land area) in Agricultural land in 1995 to that in 1996?
Keep it short and to the point. 1. What is the ratio of the Area (% of total land area) in Terrestrial protected areas in 1995 to that in 1997?
Keep it short and to the point. 1. What is the ratio of the Area (% of total land area) of Arable land in 1995 to that in 1997?
Ensure brevity in your answer.  1. What is the ratio of the Area (% of total land area) in Permanent crop land in 1995 to that in 1997?
Offer a terse response. 0.99. What is the ratio of the Area (% of total land area) of Terrestrial protected areas in 1996 to that in 1997?
Your answer should be compact. 1. What is the difference between the highest and the second highest Area (% of total land area) of Agricultural land?
Your answer should be compact. 0.1. What is the difference between the highest and the second highest Area (% of total land area) in Arable land?
Your response must be concise. 0. What is the difference between the highest and the second highest Area (% of total land area) in Permanent crop land?
Keep it short and to the point. 0. What is the difference between the highest and the lowest Area (% of total land area) of Terrestrial protected areas?
Offer a terse response. 13.6. What is the difference between the highest and the lowest Area (% of total land area) of Agricultural land?
Your response must be concise. 0.6. What is the difference between the highest and the lowest Area (% of total land area) in Arable land?
Keep it short and to the point. 0.02. What is the difference between the highest and the lowest Area (% of total land area) in Permanent crop land?
Offer a terse response. 0.01. 